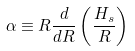<formula> <loc_0><loc_0><loc_500><loc_500>\alpha \equiv R \frac { d } { d R } \left ( \frac { H _ { s } } { R } \right )</formula> 